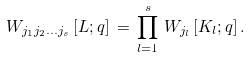Convert formula to latex. <formula><loc_0><loc_0><loc_500><loc_500>W _ { j _ { 1 } j _ { 2 } \dots j _ { s } } \, [ L ; q ] \, = \, \prod _ { l = 1 } ^ { s } \, W _ { j _ { l } } \, [ K _ { l } ; q ] \, .</formula> 